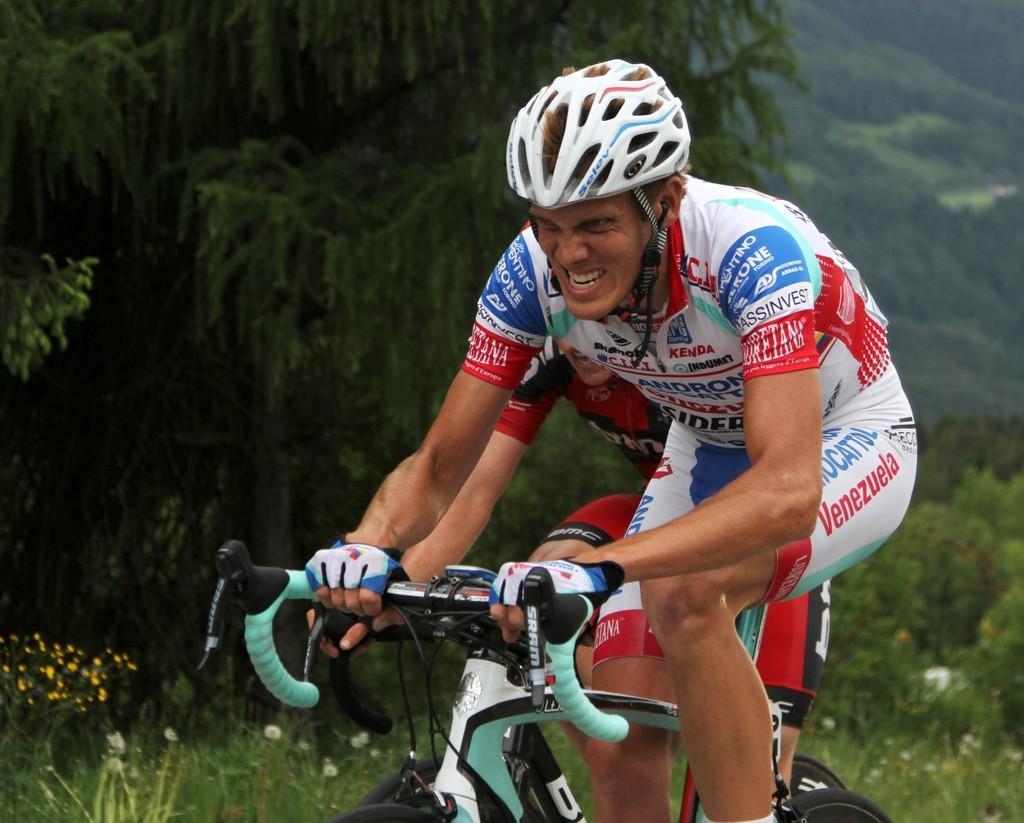Please provide a concise description of this image. In the center of the image, we can see people riding bicycles and in the background, there are trees and plants. 